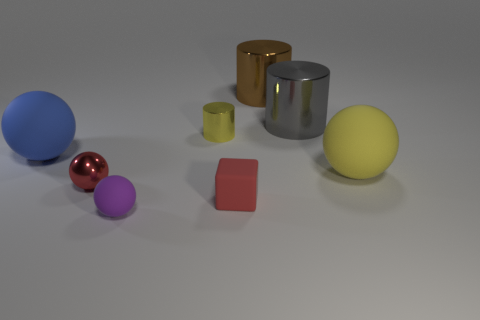There is a matte thing that is to the left of the red matte block and in front of the small metal ball; what is its shape?
Provide a succinct answer. Sphere. How many gray cylinders are in front of the large sphere that is on the left side of the tiny red rubber thing?
Give a very brief answer. 0. Are there any other things that have the same material as the big blue sphere?
Your response must be concise. Yes. What number of things are either tiny shiny things that are to the left of the tiny yellow metallic cylinder or red matte things?
Your response must be concise. 2. There is a metal object that is to the left of the small matte ball; how big is it?
Provide a succinct answer. Small. What material is the large gray cylinder?
Provide a short and direct response. Metal. What is the shape of the object that is in front of the small red object right of the tiny cylinder?
Ensure brevity in your answer.  Sphere. How many other objects are there of the same shape as the blue rubber object?
Your response must be concise. 3. Are there any big gray objects behind the brown metal thing?
Keep it short and to the point. No. The block has what color?
Offer a terse response. Red. 